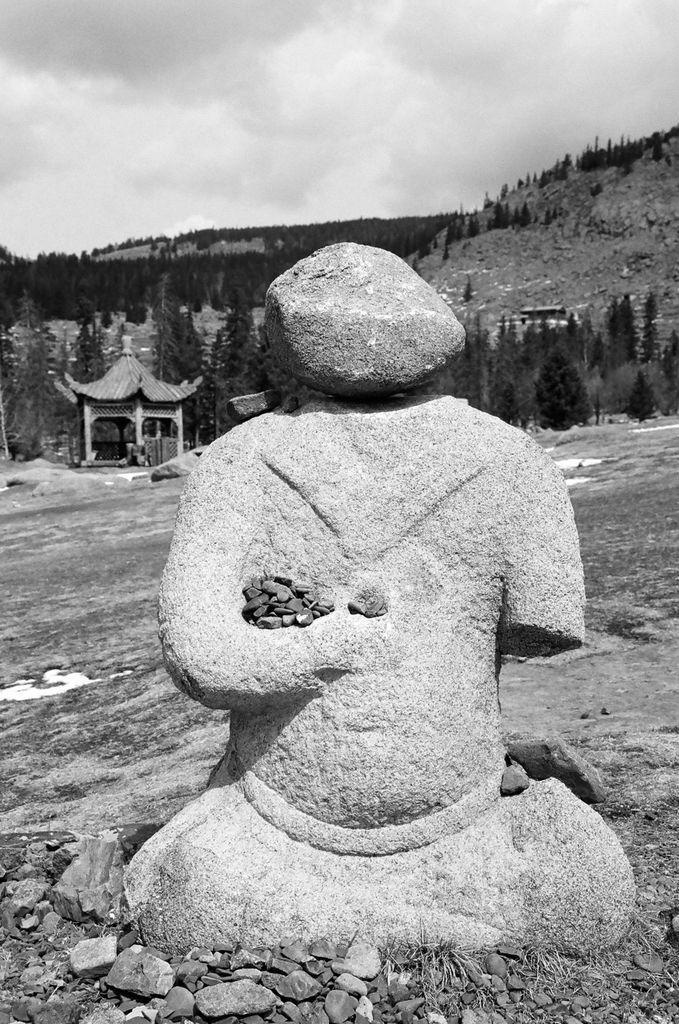Can you describe this image briefly? In this image I can see a sculpture over here. In the background I can see number of trees, the sky, a shed and I can see this image is black and white in colour. 